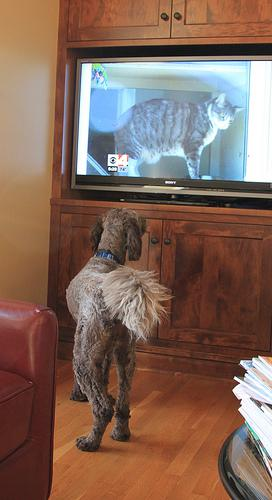Question: what type of flooring?
Choices:
A. Tile.
B. Carpet.
C. Cement.
D. Wood.
Answer with the letter. Answer: D 